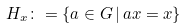<formula> <loc_0><loc_0><loc_500><loc_500>H _ { x } \colon = \{ a \in G \, | \, a x = x \}</formula> 